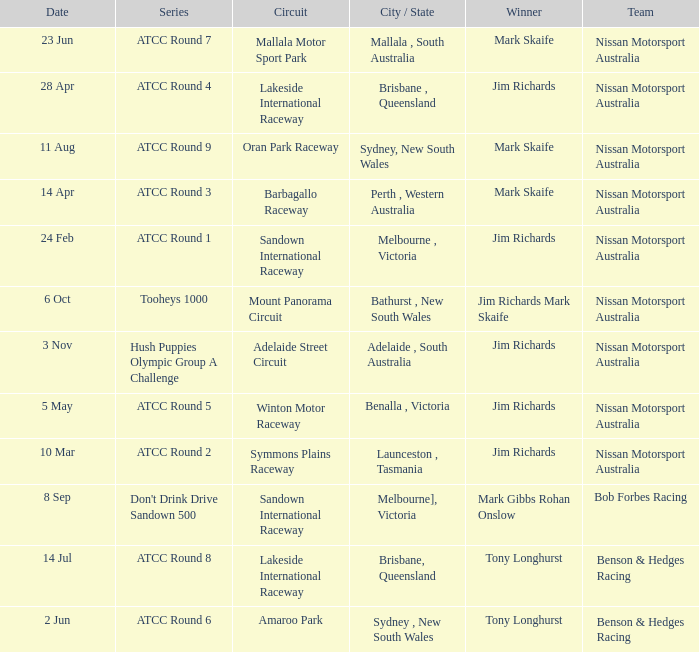What is the champion team of mark skaife in atcc round 7? Nissan Motorsport Australia. 